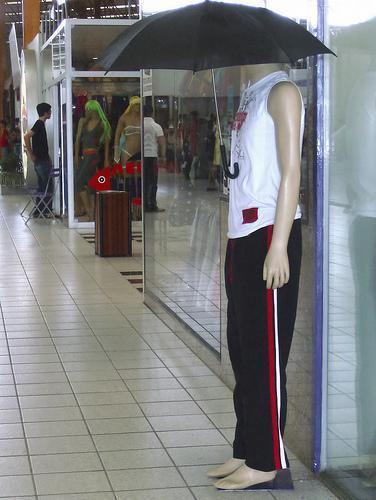How many mannequin heads are visible?
Give a very brief answer. 2. 